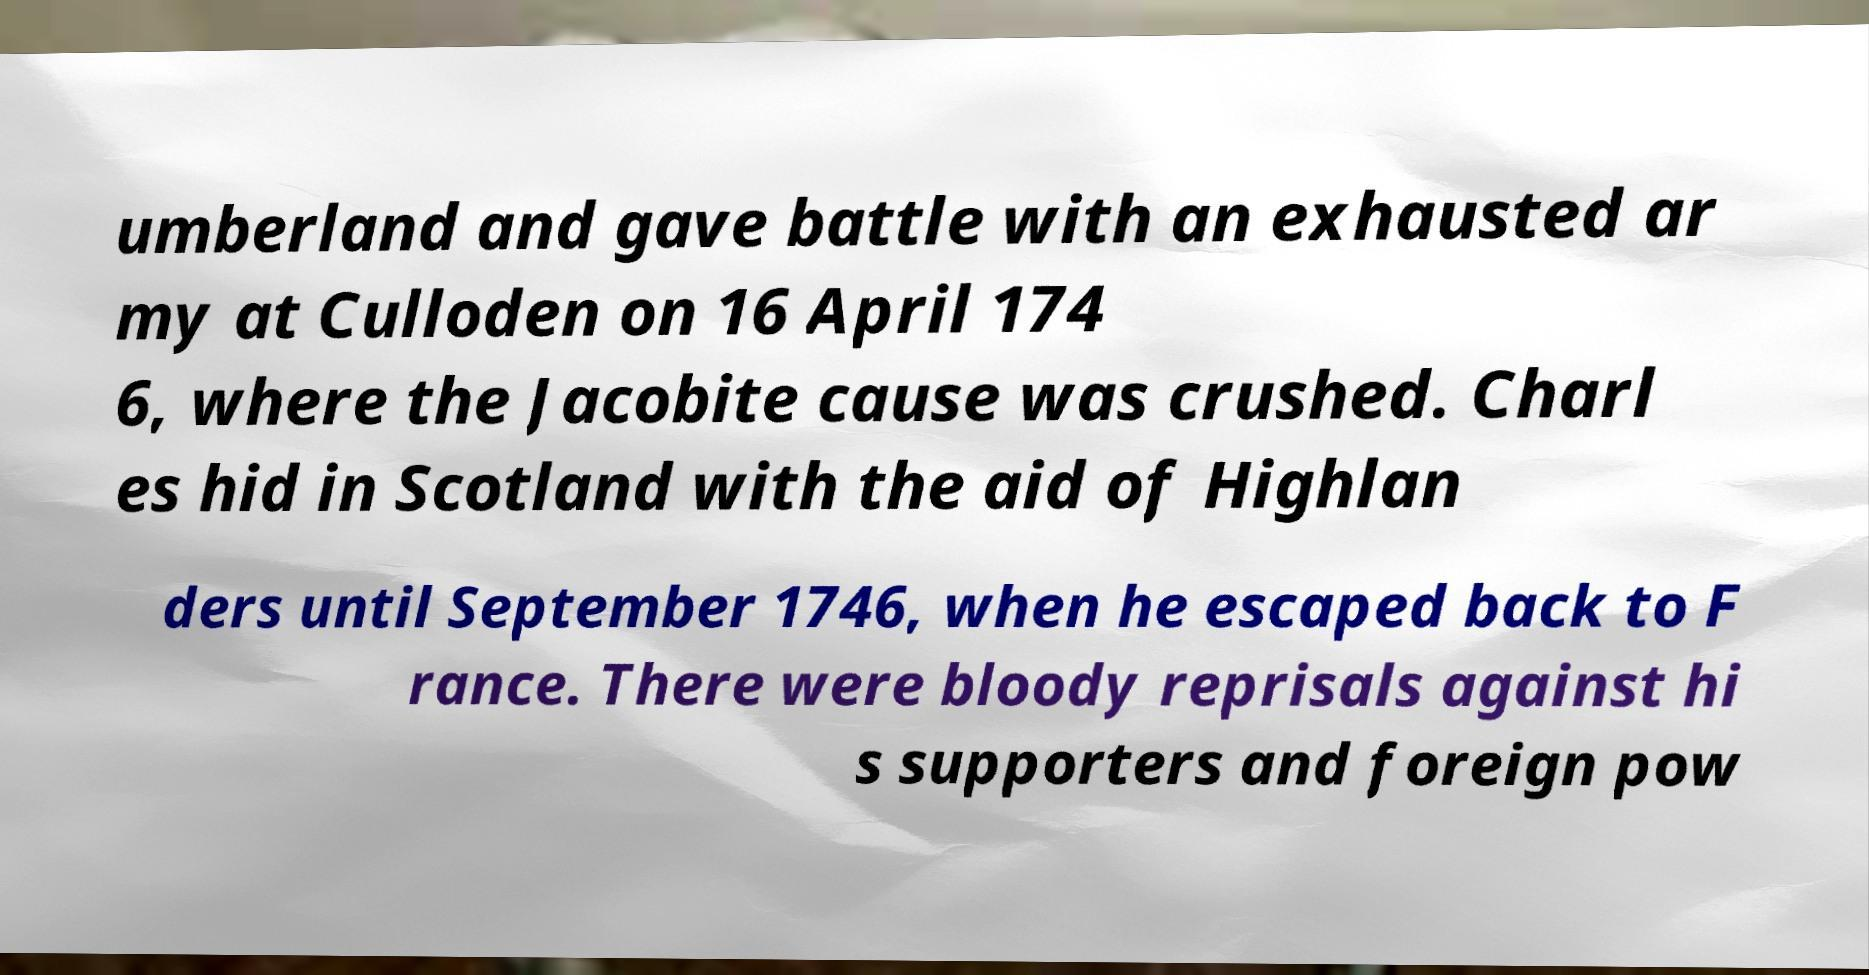There's text embedded in this image that I need extracted. Can you transcribe it verbatim? umberland and gave battle with an exhausted ar my at Culloden on 16 April 174 6, where the Jacobite cause was crushed. Charl es hid in Scotland with the aid of Highlan ders until September 1746, when he escaped back to F rance. There were bloody reprisals against hi s supporters and foreign pow 